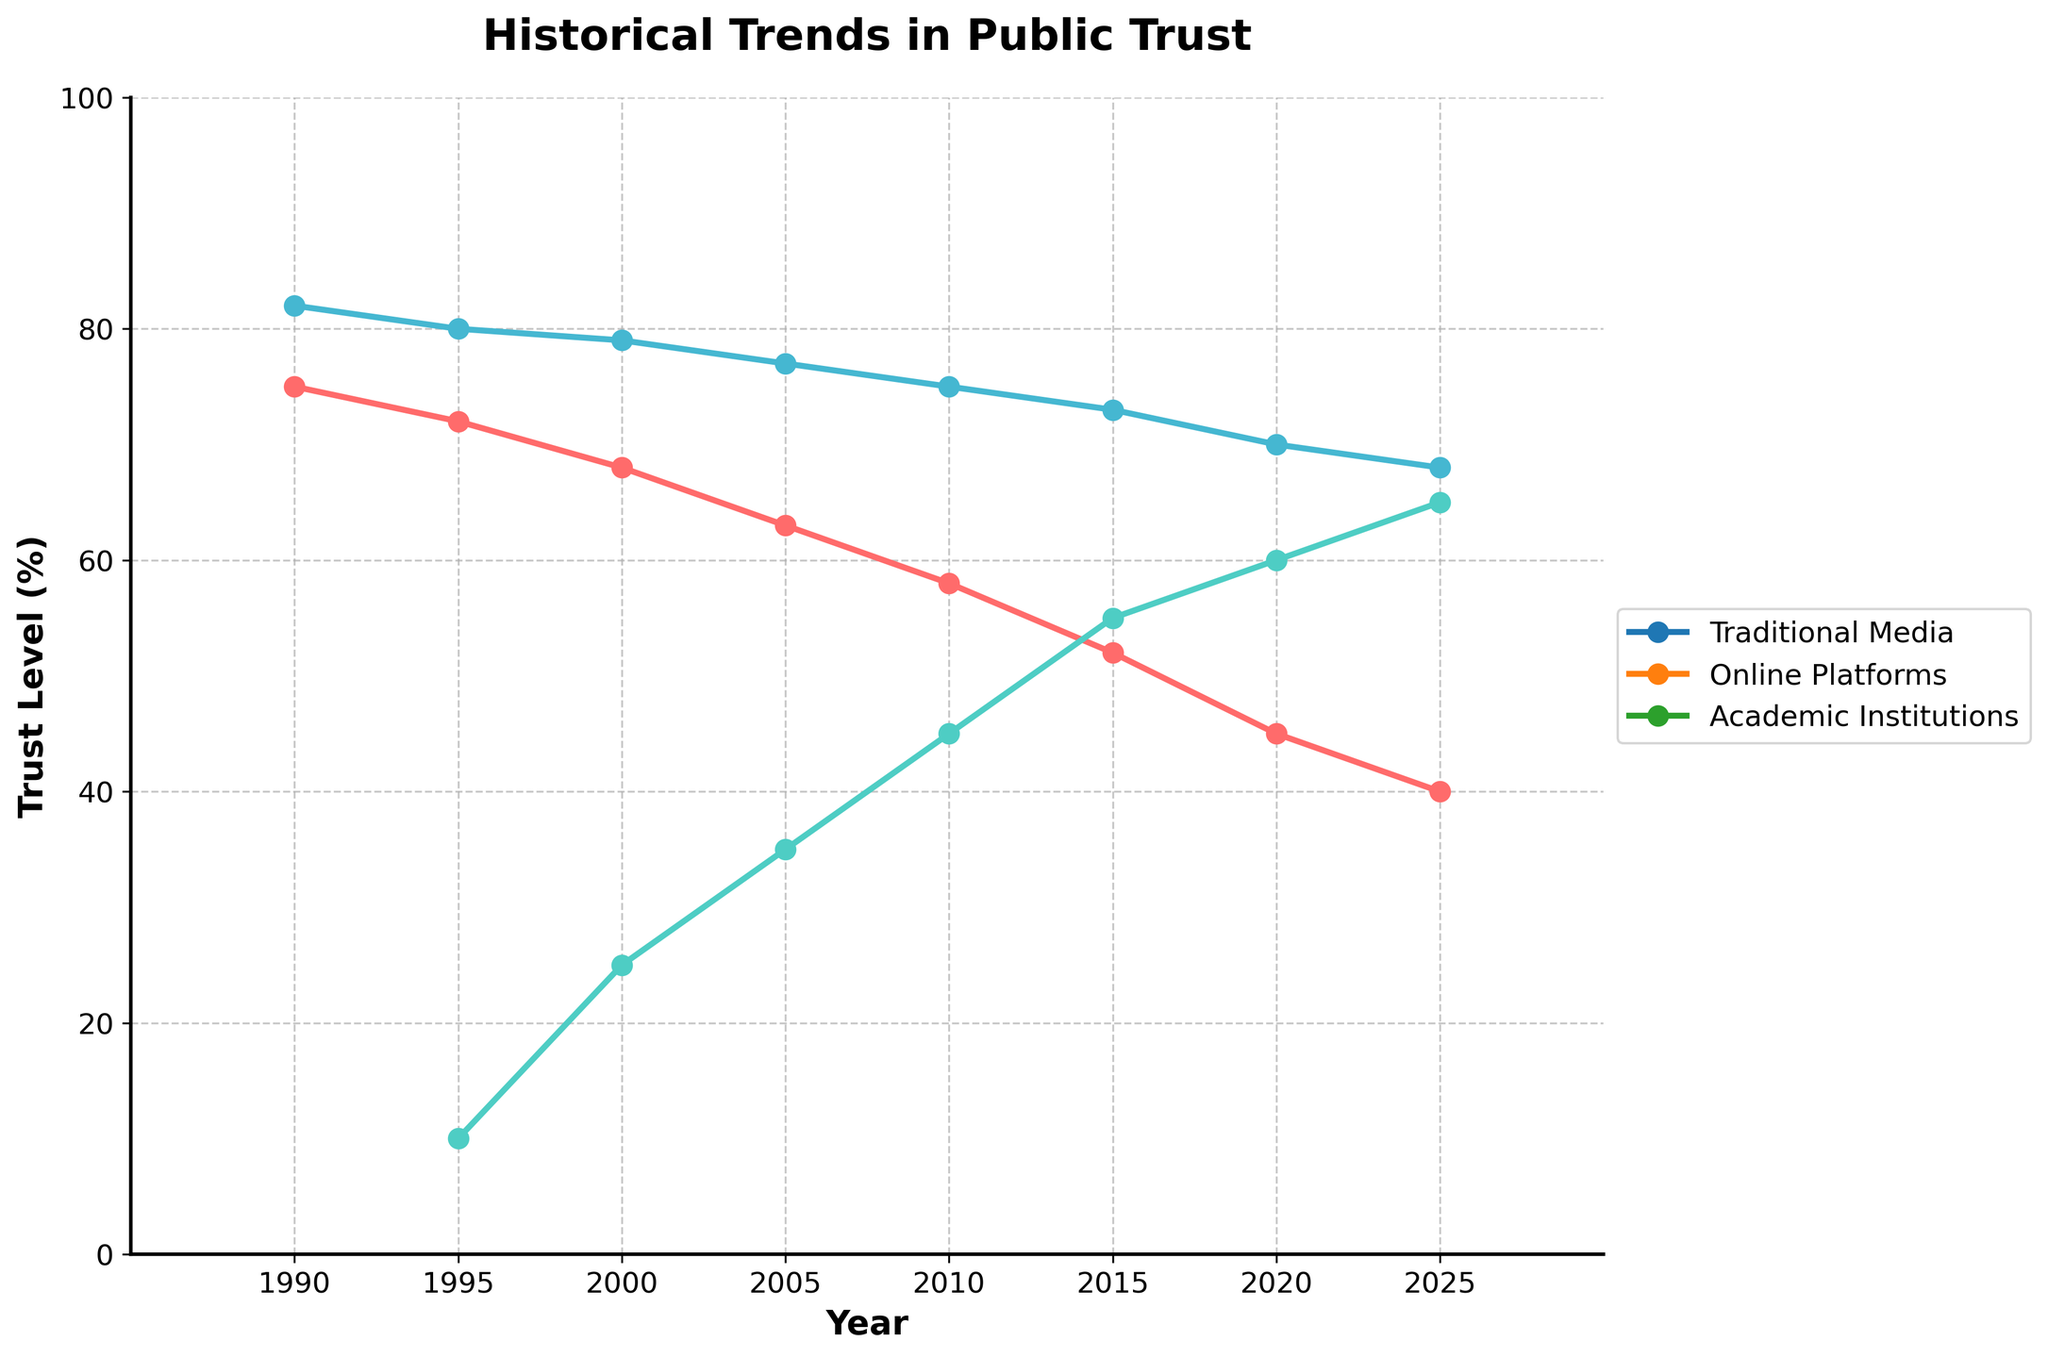What year saw the highest trust in Traditional Media? By looking at the line for Traditional Media, the peak is at the starting point in 1990, where the trust level is 75%.
Answer: 1990 How does the trust level in Academic Institutions in 2025 compare to the trust level in 1990? Checking the trust level for Academic Institutions in 1990, it's 82%. In 2025, it drops significantly to 68%. Comparing these numbers, the trust has declined by 14 percentage points.
Answer: Trust has declined by 14 percentage points Which information source had the highest trust level in 2000, and what was the value? In the year 2000, Traditional Media had a trust level of 68%, Online Platforms had 25%, and Academic Institutions had 79%. Academic Institutions had the highest trust.
Answer: Academic Institutions; 79% What is the average trust level in Online Platforms from 1995 to 2025? Summing the values for Online Platforms from 1995 (10), 2000 (25), 2005 (35), 2010 (45), 2015 (55), 2020 (60), and 2025 (65) yields 295. Dividing this by the number of years (7) gives an average of 295/7.
Answer: 42.14 How much did the trust in Traditional Media change from 1990 to 2025? Trust in Traditional Media in 1990 was 75%, and by 2025 it had dropped to 40%. The change is 75 - 40, which equals a 35 percentage point decrease.
Answer: Decreased by 35 points In which year did Online Platforms surpass Traditional Media in terms of trust? Looking at the crossing points of the lines, in the year 2015, Online Platforms (55%) surpassed Traditional Media (52%).
Answer: 2015 What is the difference in the trust levels between Academic Institutions and Online Platforms in 2020? In 2020, Academic Institutions had a trust level of 70%, while Online Platforms had 60%. The difference is calculated as 70 - 60.
Answer: 10 percentage points Which information source experienced the steepest decline in trust from 1990 to 2025? Comparing the start and end values: Traditional Media declined by 75 - 40 = 35 points, Online Platforms had no initial value, and Academic Institutions declined by 82 - 68 = 14 points. Traditional Media experienced the steepest decline.
Answer: Traditional Media In 2005, what was the combined trust level for Traditional Media and Online Platforms? Adding the trust levels in 2005: Traditional Media (63%) + Online Platforms (35%) = 98%.
Answer: 98% What is the trend in trust levels for Academic Institutions from 1990 to 2025? Visually following the line for Academic Institutions, the trust level consistently decreases over time from 82% in 1990 down to 68% in 2025.
Answer: Decreasing trend 